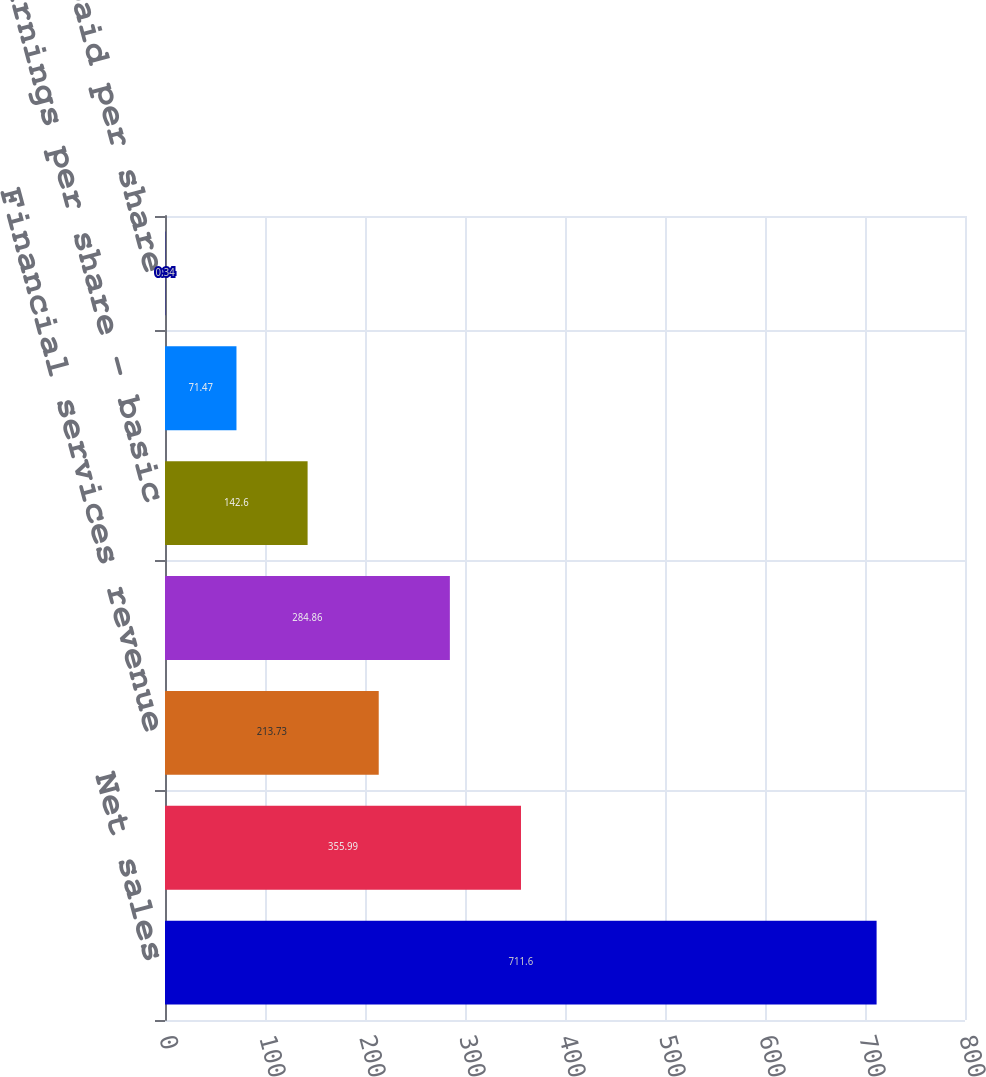Convert chart to OTSL. <chart><loc_0><loc_0><loc_500><loc_500><bar_chart><fcel>Net sales<fcel>Gross profit<fcel>Financial services revenue<fcel>Net earnings Net earnings<fcel>Earnings per share - basic<fcel>Earnings per share - diluted<fcel>Cash dividends paid per share<nl><fcel>711.6<fcel>355.99<fcel>213.73<fcel>284.86<fcel>142.6<fcel>71.47<fcel>0.34<nl></chart> 